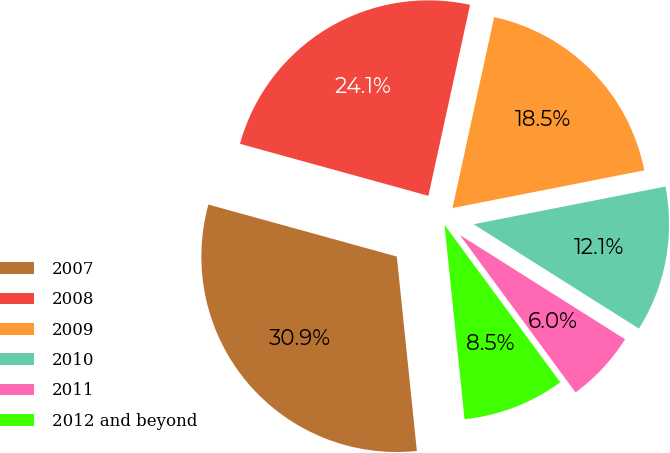Convert chart. <chart><loc_0><loc_0><loc_500><loc_500><pie_chart><fcel>2007<fcel>2008<fcel>2009<fcel>2010<fcel>2011<fcel>2012 and beyond<nl><fcel>30.92%<fcel>24.13%<fcel>18.49%<fcel>12.05%<fcel>5.95%<fcel>8.45%<nl></chart> 